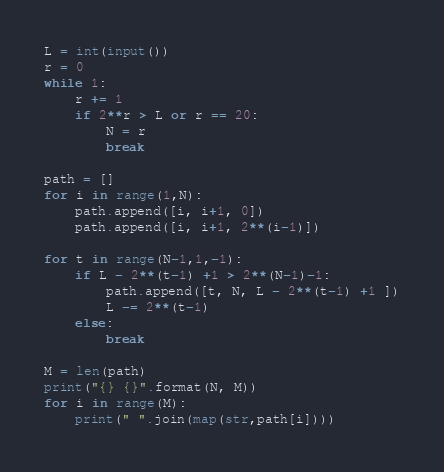<code> <loc_0><loc_0><loc_500><loc_500><_Python_>L = int(input())
r = 0
while 1:
    r += 1
    if 2**r > L or r == 20:
        N = r
        break

path = []
for i in range(1,N):
    path.append([i, i+1, 0])
    path.append([i, i+1, 2**(i-1)])

for t in range(N-1,1,-1):
    if L - 2**(t-1) +1 > 2**(N-1)-1:
        path.append([t, N, L - 2**(t-1) +1 ])
        L -= 2**(t-1)
    else:
        break

M = len(path)
print("{} {}".format(N, M))
for i in range(M):
    print(" ".join(map(str,path[i])))</code> 